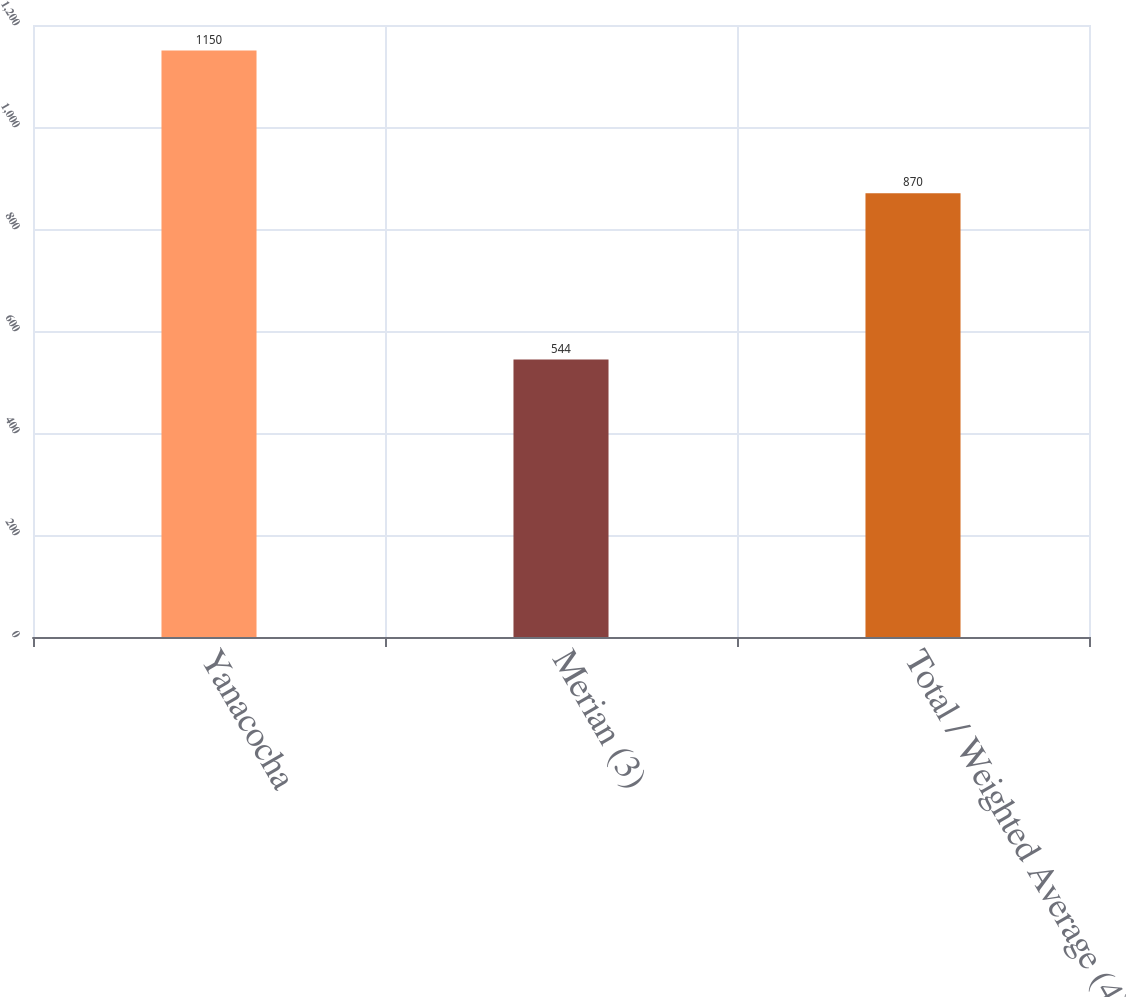<chart> <loc_0><loc_0><loc_500><loc_500><bar_chart><fcel>Yanacocha<fcel>Merian (3)<fcel>Total / Weighted Average (4)<nl><fcel>1150<fcel>544<fcel>870<nl></chart> 